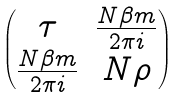<formula> <loc_0><loc_0><loc_500><loc_500>\begin{pmatrix} \tau & \frac { N \beta m } { 2 \pi i } \\ \frac { N \beta m } { 2 \pi i } & N \rho \end{pmatrix}</formula> 